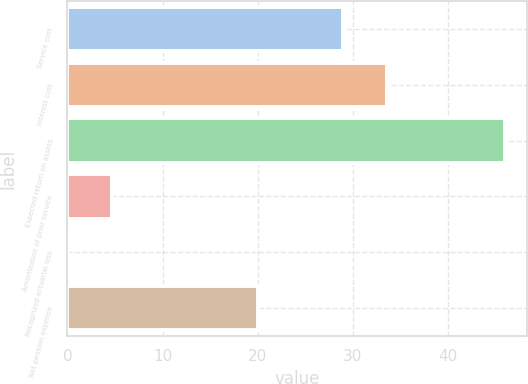<chart> <loc_0><loc_0><loc_500><loc_500><bar_chart><fcel>Service cost<fcel>Interest cost<fcel>Expected return on assets<fcel>Amortization of prior service<fcel>Recognized actuarial loss<fcel>Net pension expense<nl><fcel>29<fcel>33.59<fcel>46<fcel>4.69<fcel>0.1<fcel>20<nl></chart> 